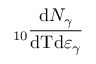<formula> <loc_0><loc_0><loc_500><loc_500>_ { 1 0 } \frac { d N _ { \gamma } } { d T d \varepsilon _ { \gamma } }</formula> 